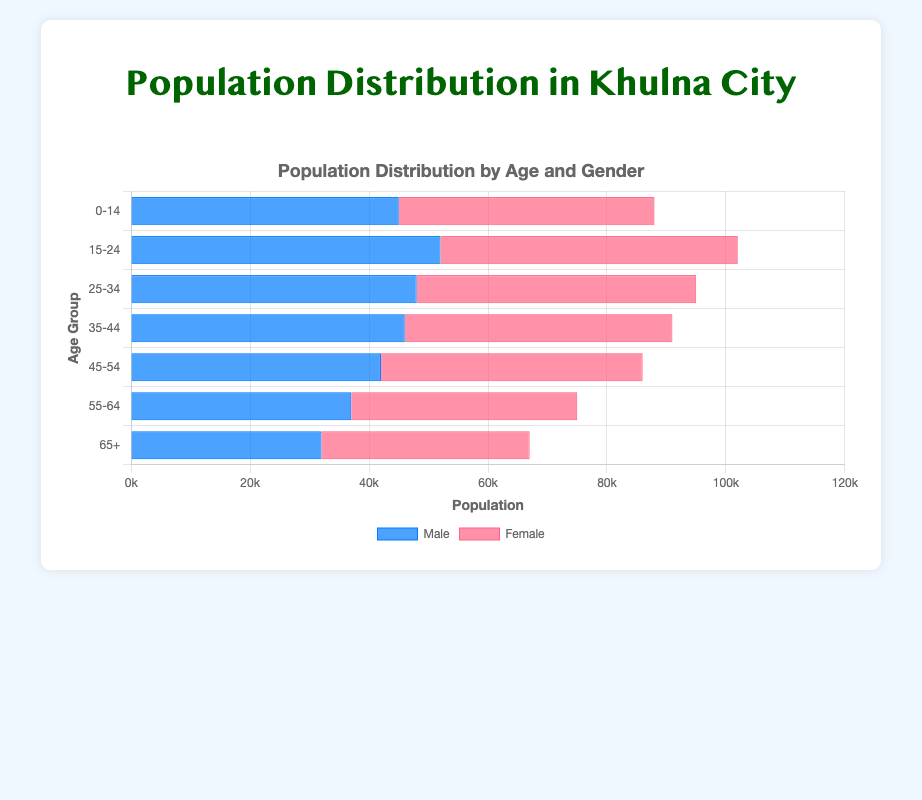Which age group has the highest male population? Look at the heights of the blue bars representing males. The "15-24" age group has the tallest bar at 52,000.
Answer: 15-24 Which age group has a larger female population than male population? Compare the red and blue bars for each age group. Only the "45-54" and "65+" age groups have taller red bars than the blue bars.
Answer: 45-54, 65+ What is the total population for the age group 35-44? Sum the population for males and females in the 35-44 age group: 46,000 (males) + 45,000 (females).
Answer: 91,000 Which age group has the smallest male population? Look at the heights of the blue bars and find the shortest one. The shortest blue bar is in the "65+" age group at 32,000.
Answer: 65+ How does the male population in the 25-34 age group compare to the female population in the same group? Compare the bars for males and females within the 25-34 age group. The male bar is slightly taller at 48,000 compared to the female bar at 47,000.
Answer: The male population is 1,000 more than the female population What is the difference between the male and female population in the age group 15-24? Subtract the female population from the male population in the 15-24 age group: 52,000 (male) - 50,000 (female).
Answer: 2,000 What is the average female population across all age groups? Calculate the sum of the female populations in all age groups (43,000 + 50,000 + 47,000 + 45,000 + 44,000 + 38,000 + 35,000) and then divide by the number of age groups (7). The sum is 302,000/7.
Answer: 43,143 What is the combined population of the 0-14 and 55-64 age groups? Add the populations for these two age groups for both genders: (45,000 + 43,000) + (37,000 + 38,000).
Answer: 163,000 Which age group has the smallest difference between male and female populations? Calculate the difference between male and female populations for each age group and find the smallest one. The "25-34" age group's difference is smallest with (48,000 - 47,000).
Answer: 25-34 What is the visual representation color for the female population? Observe the color used for the bars representing females. The bars are shown in red.
Answer: Red 